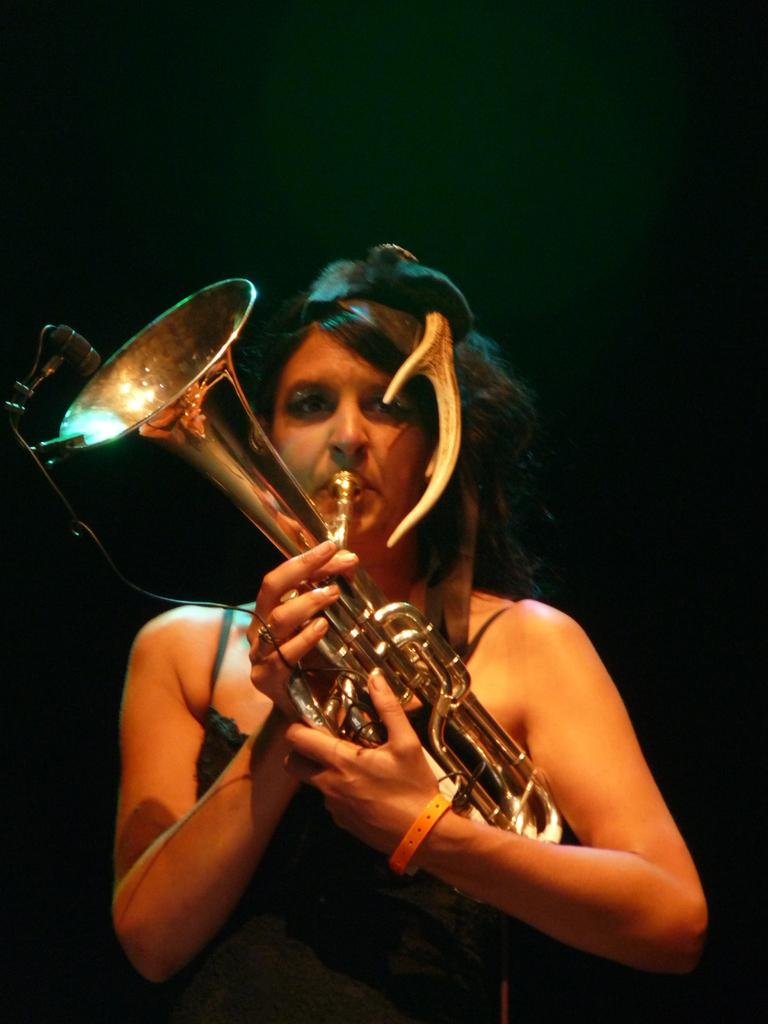Who is the main subject in the image? There is a lady in the center of the image. What is the lady holding in her hands? The lady is holding a musical instrument in her hands. How many rabbits can be seen playing in the bushes in the image? There are no rabbits or bushes present in the image; it features a lady holding a musical instrument. 